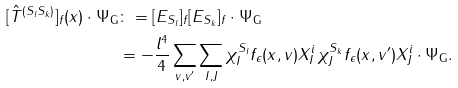Convert formula to latex. <formula><loc_0><loc_0><loc_500><loc_500>[ \hat { T } ^ { ( S _ { l } S _ { k } ) } ] _ { f } ( x ) \cdot \Psi _ { \mathsf G } & \colon = [ E _ { S _ { l } } ] _ { f } [ E _ { S _ { k } } ] _ { f } \cdot \Psi _ { \mathsf G } \\ & = - \frac { l ^ { 4 } } { 4 } \sum _ { v , v ^ { \prime } } \sum _ { I , J } \chi ^ { S _ { l } } _ { I } f _ { \epsilon } ( x , v ) X ^ { i } _ { I } \, \chi ^ { S _ { k } } _ { J } f _ { \epsilon } ( x , v ^ { \prime } ) X ^ { i } _ { J } \cdot \Psi _ { \mathsf G } .</formula> 